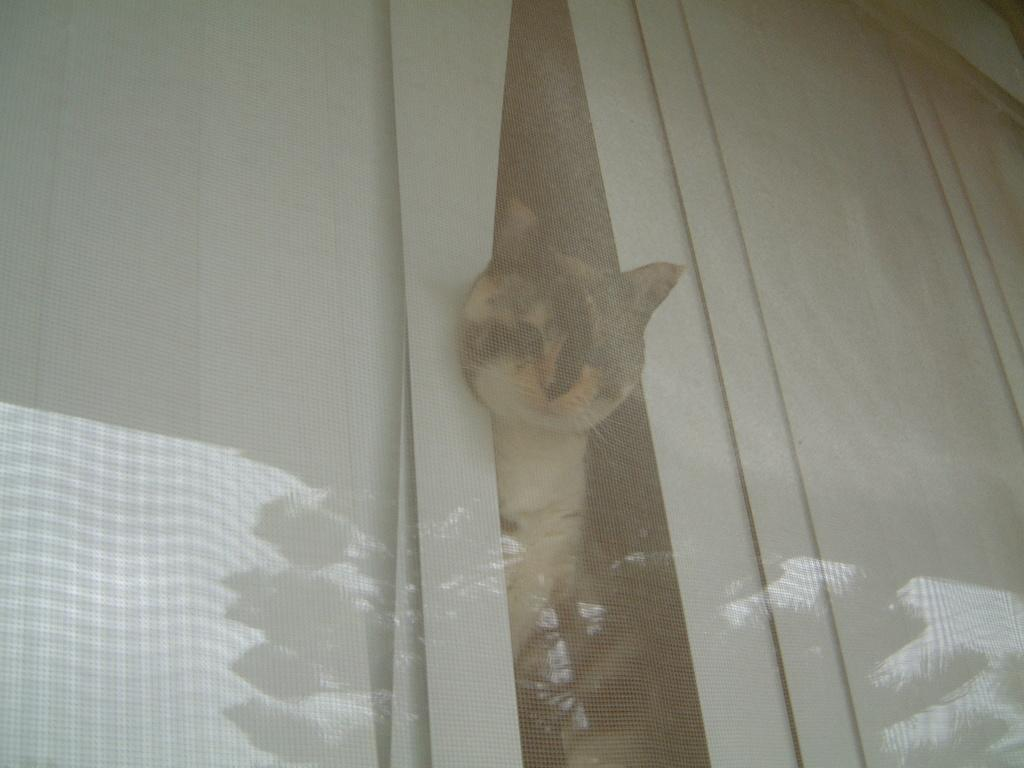What type of animal is in the image? There is a cat in the image. Where is the cat located in the image? The cat is in between curtains. What type of suit is the father wearing in the image? There is no father or suit present in the image; it features a cat between curtains. 